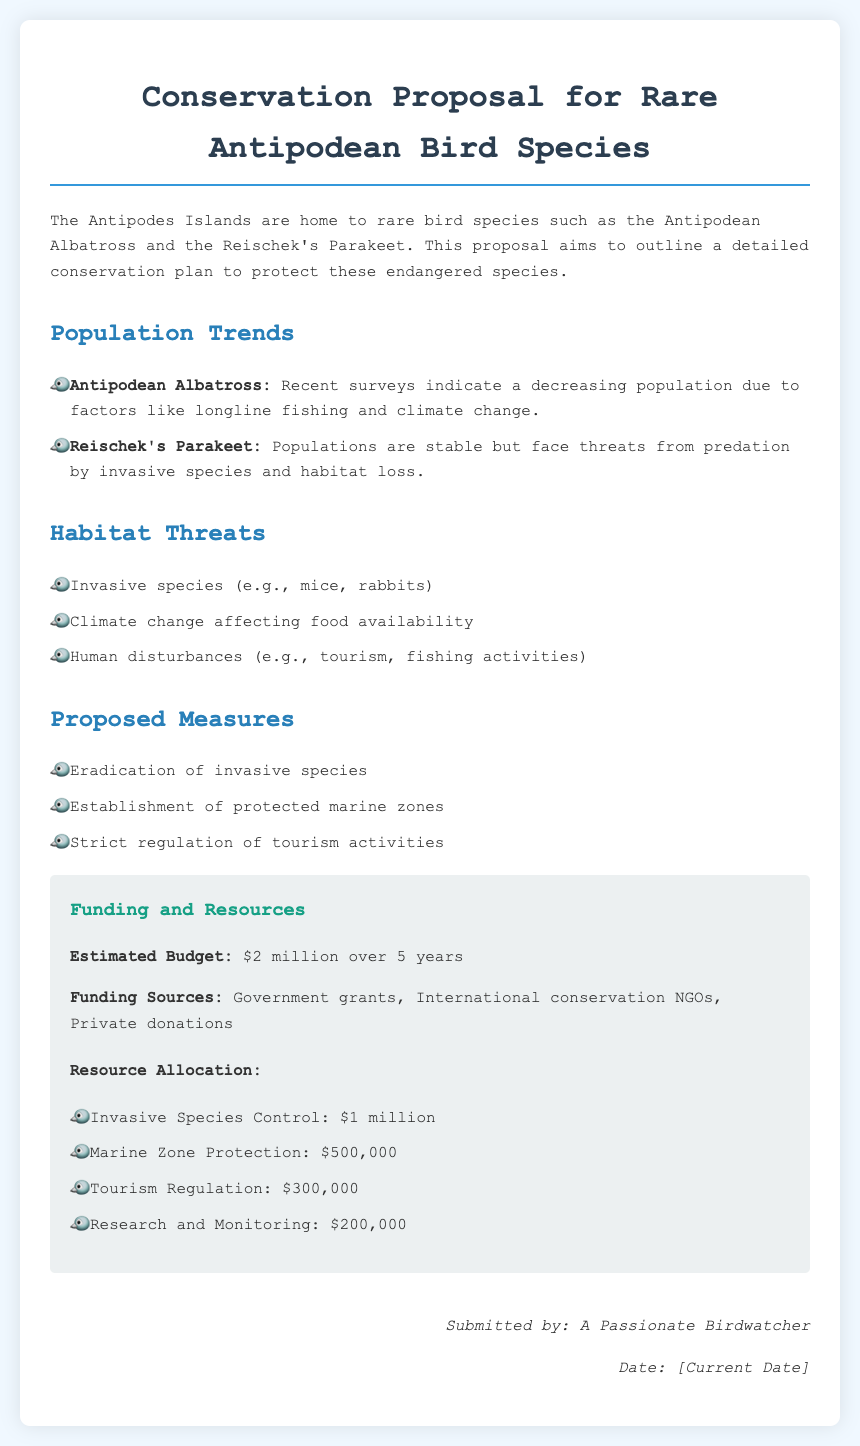What is the primary focus of the proposal? The primary focus of the proposal is to outline a detailed conservation plan to protect rare bird species on the Antipodes Islands.
Answer: Conservation plan for rare bird species How many years is the estimated budget for the conservation plan? The estimated budget for the conservation plan is divided over 5 years as stated in the document.
Answer: 5 years Which bird species has a decreasing population according to recent surveys? Recent surveys indicate that the Antipodean Albatross has a decreasing population due to various factors.
Answer: Antipodean Albatross What is the estimated budget mentioned in the proposal? The proposal states the estimated budget for conservation efforts is $2 million.
Answer: $2 million What type of species poses a threat to the Reischek's Parakeet? The document mentions that invasive species pose a threat to the Reischek's Parakeet.
Answer: Invasive species What measure is proposed to control invasive species? The proposal includes the eradication of invasive species as one of its measures.
Answer: Eradication of invasive species What is the amount allocated for research and monitoring? According to the resource allocation section, $200,000 is allocated for research and monitoring.
Answer: $200,000 Who submitted the proposal? The proposal was submitted by "A Passionate Birdwatcher" as indicated at the end of the document.
Answer: A Passionate Birdwatcher 